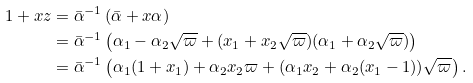<formula> <loc_0><loc_0><loc_500><loc_500>1 + x z & = \bar { \alpha } ^ { - 1 } \left ( \bar { \alpha } + x \alpha \right ) \\ & = \bar { \alpha } ^ { - 1 } \left ( \alpha _ { 1 } - \alpha _ { 2 } \sqrt { \varpi } + ( x _ { 1 } + x _ { 2 } \sqrt { \varpi } ) ( \alpha _ { 1 } + \alpha _ { 2 } \sqrt { \varpi } ) \right ) \\ & = \bar { \alpha } ^ { - 1 } \left ( \alpha _ { 1 } ( 1 + x _ { 1 } ) + \alpha _ { 2 } x _ { 2 } \varpi + ( \alpha _ { 1 } x _ { 2 } + \alpha _ { 2 } ( x _ { 1 } - 1 ) ) \sqrt { \varpi } \right ) .</formula> 